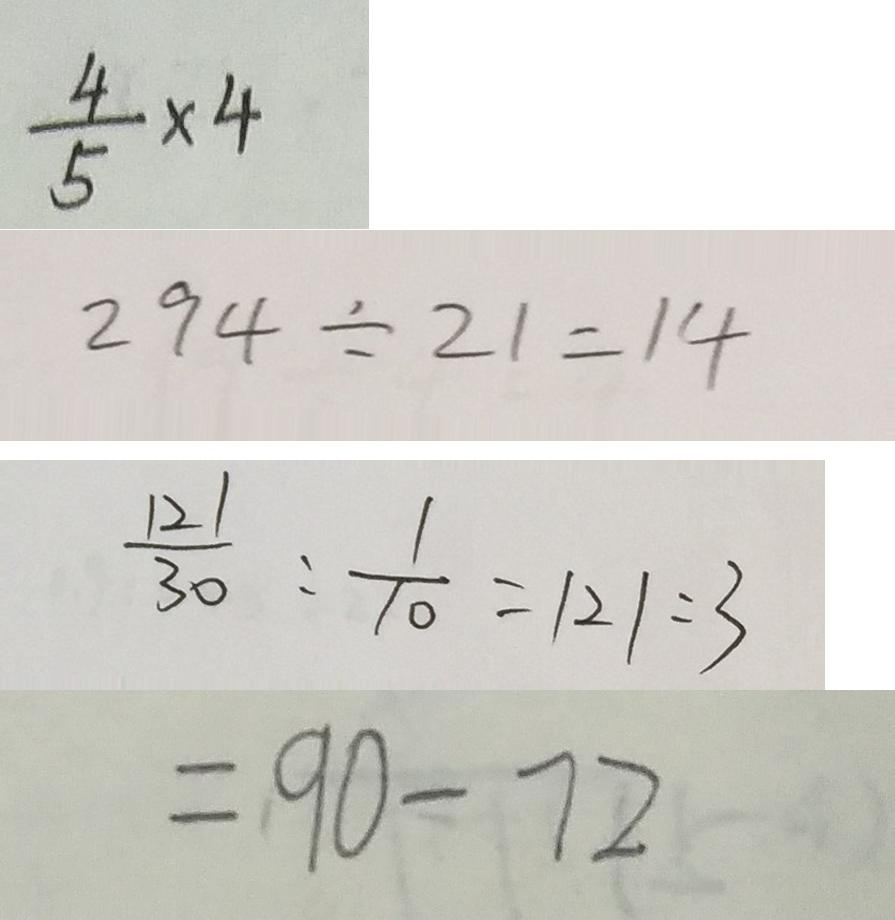<formula> <loc_0><loc_0><loc_500><loc_500>\frac { 4 } { 5 } \times 4 
 2 9 4 \div 2 1 = 1 4 
 \frac { 1 2 1 } { 3 0 } : \frac { 1 } { 1 0 } = 1 2 1 : 3 
 = 9 0 - 7 2</formula> 